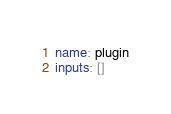Convert code to text. <code><loc_0><loc_0><loc_500><loc_500><_YAML_>name: plugin
inputs: []
</code> 